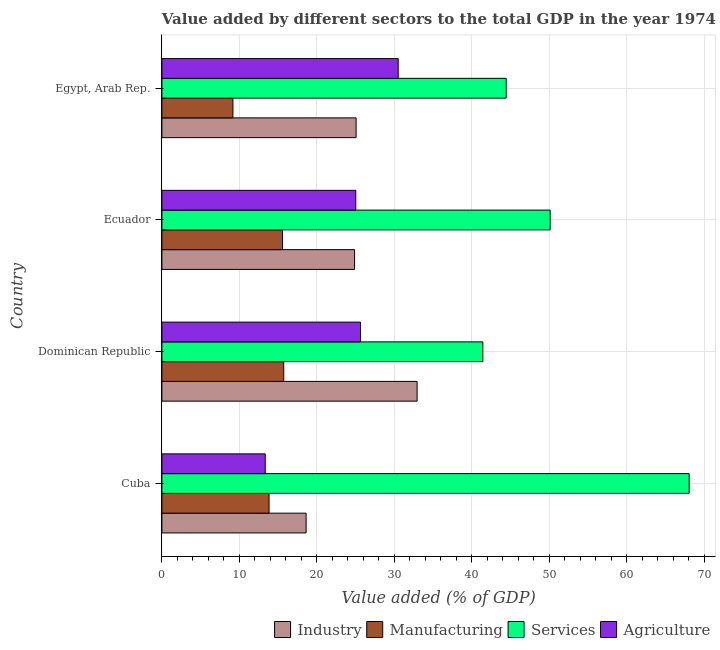How many different coloured bars are there?
Make the answer very short. 4. How many groups of bars are there?
Ensure brevity in your answer.  4. Are the number of bars per tick equal to the number of legend labels?
Ensure brevity in your answer.  Yes. Are the number of bars on each tick of the Y-axis equal?
Provide a short and direct response. Yes. How many bars are there on the 3rd tick from the bottom?
Provide a short and direct response. 4. What is the label of the 1st group of bars from the top?
Ensure brevity in your answer.  Egypt, Arab Rep. In how many cases, is the number of bars for a given country not equal to the number of legend labels?
Your answer should be compact. 0. What is the value added by industrial sector in Cuba?
Keep it short and to the point. 18.61. Across all countries, what is the maximum value added by industrial sector?
Offer a terse response. 32.94. Across all countries, what is the minimum value added by industrial sector?
Your response must be concise. 18.61. In which country was the value added by manufacturing sector maximum?
Give a very brief answer. Dominican Republic. In which country was the value added by manufacturing sector minimum?
Ensure brevity in your answer.  Egypt, Arab Rep. What is the total value added by agricultural sector in the graph?
Keep it short and to the point. 94.49. What is the difference between the value added by agricultural sector in Cuba and that in Dominican Republic?
Make the answer very short. -12.3. What is the difference between the value added by manufacturing sector in Dominican Republic and the value added by agricultural sector in Cuba?
Make the answer very short. 2.38. What is the average value added by agricultural sector per country?
Your answer should be compact. 23.62. What is the difference between the value added by manufacturing sector and value added by industrial sector in Ecuador?
Your response must be concise. -9.3. What is the ratio of the value added by manufacturing sector in Ecuador to that in Egypt, Arab Rep.?
Offer a very short reply. 1.7. Is the value added by manufacturing sector in Ecuador less than that in Egypt, Arab Rep.?
Ensure brevity in your answer.  No. What is the difference between the highest and the second highest value added by agricultural sector?
Your response must be concise. 4.86. What is the difference between the highest and the lowest value added by agricultural sector?
Provide a succinct answer. 17.16. What does the 4th bar from the top in Egypt, Arab Rep. represents?
Your answer should be compact. Industry. What does the 1st bar from the bottom in Dominican Republic represents?
Make the answer very short. Industry. How many bars are there?
Your answer should be compact. 16. Are the values on the major ticks of X-axis written in scientific E-notation?
Your answer should be compact. No. Where does the legend appear in the graph?
Give a very brief answer. Bottom right. What is the title of the graph?
Your answer should be very brief. Value added by different sectors to the total GDP in the year 1974. What is the label or title of the X-axis?
Provide a succinct answer. Value added (% of GDP). What is the Value added (% of GDP) in Industry in Cuba?
Provide a succinct answer. 18.61. What is the Value added (% of GDP) in Manufacturing in Cuba?
Make the answer very short. 13.83. What is the Value added (% of GDP) of Services in Cuba?
Ensure brevity in your answer.  68.05. What is the Value added (% of GDP) of Agriculture in Cuba?
Give a very brief answer. 13.34. What is the Value added (% of GDP) in Industry in Dominican Republic?
Provide a succinct answer. 32.94. What is the Value added (% of GDP) of Manufacturing in Dominican Republic?
Give a very brief answer. 15.72. What is the Value added (% of GDP) in Services in Dominican Republic?
Offer a terse response. 41.42. What is the Value added (% of GDP) of Agriculture in Dominican Republic?
Keep it short and to the point. 25.64. What is the Value added (% of GDP) in Industry in Ecuador?
Offer a terse response. 24.87. What is the Value added (% of GDP) of Manufacturing in Ecuador?
Your response must be concise. 15.56. What is the Value added (% of GDP) in Services in Ecuador?
Offer a terse response. 50.11. What is the Value added (% of GDP) in Agriculture in Ecuador?
Ensure brevity in your answer.  25.02. What is the Value added (% of GDP) of Industry in Egypt, Arab Rep.?
Make the answer very short. 25.07. What is the Value added (% of GDP) in Manufacturing in Egypt, Arab Rep.?
Keep it short and to the point. 9.17. What is the Value added (% of GDP) in Services in Egypt, Arab Rep.?
Keep it short and to the point. 44.44. What is the Value added (% of GDP) in Agriculture in Egypt, Arab Rep.?
Give a very brief answer. 30.5. Across all countries, what is the maximum Value added (% of GDP) of Industry?
Provide a succinct answer. 32.94. Across all countries, what is the maximum Value added (% of GDP) of Manufacturing?
Offer a very short reply. 15.72. Across all countries, what is the maximum Value added (% of GDP) of Services?
Your answer should be compact. 68.05. Across all countries, what is the maximum Value added (% of GDP) of Agriculture?
Offer a very short reply. 30.5. Across all countries, what is the minimum Value added (% of GDP) in Industry?
Offer a terse response. 18.61. Across all countries, what is the minimum Value added (% of GDP) of Manufacturing?
Your response must be concise. 9.17. Across all countries, what is the minimum Value added (% of GDP) in Services?
Your answer should be very brief. 41.42. Across all countries, what is the minimum Value added (% of GDP) in Agriculture?
Provide a succinct answer. 13.34. What is the total Value added (% of GDP) in Industry in the graph?
Ensure brevity in your answer.  101.48. What is the total Value added (% of GDP) in Manufacturing in the graph?
Offer a terse response. 54.28. What is the total Value added (% of GDP) of Services in the graph?
Provide a succinct answer. 204.02. What is the total Value added (% of GDP) of Agriculture in the graph?
Keep it short and to the point. 94.49. What is the difference between the Value added (% of GDP) of Industry in Cuba and that in Dominican Republic?
Provide a short and direct response. -14.33. What is the difference between the Value added (% of GDP) of Manufacturing in Cuba and that in Dominican Republic?
Your response must be concise. -1.89. What is the difference between the Value added (% of GDP) in Services in Cuba and that in Dominican Republic?
Offer a terse response. 26.62. What is the difference between the Value added (% of GDP) of Agriculture in Cuba and that in Dominican Republic?
Your answer should be very brief. -12.3. What is the difference between the Value added (% of GDP) in Industry in Cuba and that in Ecuador?
Your answer should be compact. -6.25. What is the difference between the Value added (% of GDP) in Manufacturing in Cuba and that in Ecuador?
Your answer should be very brief. -1.73. What is the difference between the Value added (% of GDP) in Services in Cuba and that in Ecuador?
Offer a terse response. 17.94. What is the difference between the Value added (% of GDP) of Agriculture in Cuba and that in Ecuador?
Keep it short and to the point. -11.68. What is the difference between the Value added (% of GDP) of Industry in Cuba and that in Egypt, Arab Rep.?
Provide a succinct answer. -6.45. What is the difference between the Value added (% of GDP) of Manufacturing in Cuba and that in Egypt, Arab Rep.?
Offer a terse response. 4.66. What is the difference between the Value added (% of GDP) of Services in Cuba and that in Egypt, Arab Rep.?
Give a very brief answer. 23.61. What is the difference between the Value added (% of GDP) in Agriculture in Cuba and that in Egypt, Arab Rep.?
Provide a succinct answer. -17.16. What is the difference between the Value added (% of GDP) of Industry in Dominican Republic and that in Ecuador?
Provide a short and direct response. 8.07. What is the difference between the Value added (% of GDP) in Manufacturing in Dominican Republic and that in Ecuador?
Your answer should be compact. 0.16. What is the difference between the Value added (% of GDP) in Services in Dominican Republic and that in Ecuador?
Your answer should be very brief. -8.69. What is the difference between the Value added (% of GDP) in Agriculture in Dominican Republic and that in Ecuador?
Ensure brevity in your answer.  0.61. What is the difference between the Value added (% of GDP) in Industry in Dominican Republic and that in Egypt, Arab Rep.?
Offer a very short reply. 7.87. What is the difference between the Value added (% of GDP) of Manufacturing in Dominican Republic and that in Egypt, Arab Rep.?
Provide a succinct answer. 6.56. What is the difference between the Value added (% of GDP) in Services in Dominican Republic and that in Egypt, Arab Rep.?
Provide a succinct answer. -3.01. What is the difference between the Value added (% of GDP) in Agriculture in Dominican Republic and that in Egypt, Arab Rep.?
Your response must be concise. -4.86. What is the difference between the Value added (% of GDP) in Industry in Ecuador and that in Egypt, Arab Rep.?
Your answer should be compact. -0.2. What is the difference between the Value added (% of GDP) in Manufacturing in Ecuador and that in Egypt, Arab Rep.?
Give a very brief answer. 6.4. What is the difference between the Value added (% of GDP) in Services in Ecuador and that in Egypt, Arab Rep.?
Your answer should be very brief. 5.67. What is the difference between the Value added (% of GDP) in Agriculture in Ecuador and that in Egypt, Arab Rep.?
Ensure brevity in your answer.  -5.48. What is the difference between the Value added (% of GDP) in Industry in Cuba and the Value added (% of GDP) in Manufacturing in Dominican Republic?
Your answer should be compact. 2.89. What is the difference between the Value added (% of GDP) in Industry in Cuba and the Value added (% of GDP) in Services in Dominican Republic?
Your answer should be compact. -22.81. What is the difference between the Value added (% of GDP) of Industry in Cuba and the Value added (% of GDP) of Agriculture in Dominican Republic?
Provide a succinct answer. -7.02. What is the difference between the Value added (% of GDP) of Manufacturing in Cuba and the Value added (% of GDP) of Services in Dominican Republic?
Give a very brief answer. -27.59. What is the difference between the Value added (% of GDP) in Manufacturing in Cuba and the Value added (% of GDP) in Agriculture in Dominican Republic?
Make the answer very short. -11.81. What is the difference between the Value added (% of GDP) of Services in Cuba and the Value added (% of GDP) of Agriculture in Dominican Republic?
Make the answer very short. 42.41. What is the difference between the Value added (% of GDP) in Industry in Cuba and the Value added (% of GDP) in Manufacturing in Ecuador?
Ensure brevity in your answer.  3.05. What is the difference between the Value added (% of GDP) of Industry in Cuba and the Value added (% of GDP) of Services in Ecuador?
Make the answer very short. -31.5. What is the difference between the Value added (% of GDP) in Industry in Cuba and the Value added (% of GDP) in Agriculture in Ecuador?
Offer a terse response. -6.41. What is the difference between the Value added (% of GDP) of Manufacturing in Cuba and the Value added (% of GDP) of Services in Ecuador?
Give a very brief answer. -36.28. What is the difference between the Value added (% of GDP) in Manufacturing in Cuba and the Value added (% of GDP) in Agriculture in Ecuador?
Make the answer very short. -11.19. What is the difference between the Value added (% of GDP) in Services in Cuba and the Value added (% of GDP) in Agriculture in Ecuador?
Your answer should be very brief. 43.03. What is the difference between the Value added (% of GDP) of Industry in Cuba and the Value added (% of GDP) of Manufacturing in Egypt, Arab Rep.?
Ensure brevity in your answer.  9.45. What is the difference between the Value added (% of GDP) in Industry in Cuba and the Value added (% of GDP) in Services in Egypt, Arab Rep.?
Keep it short and to the point. -25.82. What is the difference between the Value added (% of GDP) of Industry in Cuba and the Value added (% of GDP) of Agriculture in Egypt, Arab Rep.?
Your answer should be very brief. -11.88. What is the difference between the Value added (% of GDP) in Manufacturing in Cuba and the Value added (% of GDP) in Services in Egypt, Arab Rep.?
Provide a short and direct response. -30.61. What is the difference between the Value added (% of GDP) of Manufacturing in Cuba and the Value added (% of GDP) of Agriculture in Egypt, Arab Rep.?
Make the answer very short. -16.67. What is the difference between the Value added (% of GDP) in Services in Cuba and the Value added (% of GDP) in Agriculture in Egypt, Arab Rep.?
Provide a short and direct response. 37.55. What is the difference between the Value added (% of GDP) in Industry in Dominican Republic and the Value added (% of GDP) in Manufacturing in Ecuador?
Ensure brevity in your answer.  17.38. What is the difference between the Value added (% of GDP) in Industry in Dominican Republic and the Value added (% of GDP) in Services in Ecuador?
Provide a succinct answer. -17.17. What is the difference between the Value added (% of GDP) in Industry in Dominican Republic and the Value added (% of GDP) in Agriculture in Ecuador?
Make the answer very short. 7.92. What is the difference between the Value added (% of GDP) of Manufacturing in Dominican Republic and the Value added (% of GDP) of Services in Ecuador?
Provide a succinct answer. -34.39. What is the difference between the Value added (% of GDP) in Manufacturing in Dominican Republic and the Value added (% of GDP) in Agriculture in Ecuador?
Provide a succinct answer. -9.3. What is the difference between the Value added (% of GDP) in Services in Dominican Republic and the Value added (% of GDP) in Agriculture in Ecuador?
Offer a terse response. 16.4. What is the difference between the Value added (% of GDP) in Industry in Dominican Republic and the Value added (% of GDP) in Manufacturing in Egypt, Arab Rep.?
Offer a terse response. 23.77. What is the difference between the Value added (% of GDP) of Industry in Dominican Republic and the Value added (% of GDP) of Services in Egypt, Arab Rep.?
Provide a short and direct response. -11.5. What is the difference between the Value added (% of GDP) of Industry in Dominican Republic and the Value added (% of GDP) of Agriculture in Egypt, Arab Rep.?
Your answer should be very brief. 2.44. What is the difference between the Value added (% of GDP) in Manufacturing in Dominican Republic and the Value added (% of GDP) in Services in Egypt, Arab Rep.?
Your answer should be compact. -28.71. What is the difference between the Value added (% of GDP) of Manufacturing in Dominican Republic and the Value added (% of GDP) of Agriculture in Egypt, Arab Rep.?
Provide a short and direct response. -14.78. What is the difference between the Value added (% of GDP) in Services in Dominican Republic and the Value added (% of GDP) in Agriculture in Egypt, Arab Rep.?
Provide a short and direct response. 10.93. What is the difference between the Value added (% of GDP) of Industry in Ecuador and the Value added (% of GDP) of Manufacturing in Egypt, Arab Rep.?
Keep it short and to the point. 15.7. What is the difference between the Value added (% of GDP) of Industry in Ecuador and the Value added (% of GDP) of Services in Egypt, Arab Rep.?
Provide a succinct answer. -19.57. What is the difference between the Value added (% of GDP) in Industry in Ecuador and the Value added (% of GDP) in Agriculture in Egypt, Arab Rep.?
Provide a succinct answer. -5.63. What is the difference between the Value added (% of GDP) in Manufacturing in Ecuador and the Value added (% of GDP) in Services in Egypt, Arab Rep.?
Your answer should be very brief. -28.87. What is the difference between the Value added (% of GDP) of Manufacturing in Ecuador and the Value added (% of GDP) of Agriculture in Egypt, Arab Rep.?
Make the answer very short. -14.94. What is the difference between the Value added (% of GDP) in Services in Ecuador and the Value added (% of GDP) in Agriculture in Egypt, Arab Rep.?
Your answer should be very brief. 19.61. What is the average Value added (% of GDP) of Industry per country?
Offer a terse response. 25.37. What is the average Value added (% of GDP) in Manufacturing per country?
Offer a terse response. 13.57. What is the average Value added (% of GDP) in Services per country?
Provide a succinct answer. 51.01. What is the average Value added (% of GDP) of Agriculture per country?
Your answer should be compact. 23.62. What is the difference between the Value added (% of GDP) of Industry and Value added (% of GDP) of Manufacturing in Cuba?
Keep it short and to the point. 4.78. What is the difference between the Value added (% of GDP) in Industry and Value added (% of GDP) in Services in Cuba?
Give a very brief answer. -49.44. What is the difference between the Value added (% of GDP) of Industry and Value added (% of GDP) of Agriculture in Cuba?
Offer a very short reply. 5.28. What is the difference between the Value added (% of GDP) in Manufacturing and Value added (% of GDP) in Services in Cuba?
Your answer should be very brief. -54.22. What is the difference between the Value added (% of GDP) of Manufacturing and Value added (% of GDP) of Agriculture in Cuba?
Your response must be concise. 0.49. What is the difference between the Value added (% of GDP) in Services and Value added (% of GDP) in Agriculture in Cuba?
Offer a very short reply. 54.71. What is the difference between the Value added (% of GDP) of Industry and Value added (% of GDP) of Manufacturing in Dominican Republic?
Offer a very short reply. 17.22. What is the difference between the Value added (% of GDP) of Industry and Value added (% of GDP) of Services in Dominican Republic?
Keep it short and to the point. -8.48. What is the difference between the Value added (% of GDP) of Industry and Value added (% of GDP) of Agriculture in Dominican Republic?
Ensure brevity in your answer.  7.3. What is the difference between the Value added (% of GDP) of Manufacturing and Value added (% of GDP) of Services in Dominican Republic?
Your response must be concise. -25.7. What is the difference between the Value added (% of GDP) in Manufacturing and Value added (% of GDP) in Agriculture in Dominican Republic?
Make the answer very short. -9.91. What is the difference between the Value added (% of GDP) in Services and Value added (% of GDP) in Agriculture in Dominican Republic?
Your response must be concise. 15.79. What is the difference between the Value added (% of GDP) of Industry and Value added (% of GDP) of Manufacturing in Ecuador?
Offer a very short reply. 9.3. What is the difference between the Value added (% of GDP) in Industry and Value added (% of GDP) in Services in Ecuador?
Offer a terse response. -25.24. What is the difference between the Value added (% of GDP) of Industry and Value added (% of GDP) of Agriculture in Ecuador?
Offer a very short reply. -0.16. What is the difference between the Value added (% of GDP) in Manufacturing and Value added (% of GDP) in Services in Ecuador?
Make the answer very short. -34.55. What is the difference between the Value added (% of GDP) of Manufacturing and Value added (% of GDP) of Agriculture in Ecuador?
Offer a terse response. -9.46. What is the difference between the Value added (% of GDP) in Services and Value added (% of GDP) in Agriculture in Ecuador?
Give a very brief answer. 25.09. What is the difference between the Value added (% of GDP) in Industry and Value added (% of GDP) in Manufacturing in Egypt, Arab Rep.?
Your answer should be very brief. 15.9. What is the difference between the Value added (% of GDP) in Industry and Value added (% of GDP) in Services in Egypt, Arab Rep.?
Provide a short and direct response. -19.37. What is the difference between the Value added (% of GDP) in Industry and Value added (% of GDP) in Agriculture in Egypt, Arab Rep.?
Your answer should be very brief. -5.43. What is the difference between the Value added (% of GDP) of Manufacturing and Value added (% of GDP) of Services in Egypt, Arab Rep.?
Keep it short and to the point. -35.27. What is the difference between the Value added (% of GDP) in Manufacturing and Value added (% of GDP) in Agriculture in Egypt, Arab Rep.?
Give a very brief answer. -21.33. What is the difference between the Value added (% of GDP) in Services and Value added (% of GDP) in Agriculture in Egypt, Arab Rep.?
Your answer should be compact. 13.94. What is the ratio of the Value added (% of GDP) in Industry in Cuba to that in Dominican Republic?
Ensure brevity in your answer.  0.57. What is the ratio of the Value added (% of GDP) of Manufacturing in Cuba to that in Dominican Republic?
Give a very brief answer. 0.88. What is the ratio of the Value added (% of GDP) in Services in Cuba to that in Dominican Republic?
Provide a succinct answer. 1.64. What is the ratio of the Value added (% of GDP) of Agriculture in Cuba to that in Dominican Republic?
Give a very brief answer. 0.52. What is the ratio of the Value added (% of GDP) of Industry in Cuba to that in Ecuador?
Ensure brevity in your answer.  0.75. What is the ratio of the Value added (% of GDP) in Manufacturing in Cuba to that in Ecuador?
Offer a terse response. 0.89. What is the ratio of the Value added (% of GDP) of Services in Cuba to that in Ecuador?
Offer a very short reply. 1.36. What is the ratio of the Value added (% of GDP) in Agriculture in Cuba to that in Ecuador?
Your response must be concise. 0.53. What is the ratio of the Value added (% of GDP) of Industry in Cuba to that in Egypt, Arab Rep.?
Your answer should be very brief. 0.74. What is the ratio of the Value added (% of GDP) in Manufacturing in Cuba to that in Egypt, Arab Rep.?
Your response must be concise. 1.51. What is the ratio of the Value added (% of GDP) in Services in Cuba to that in Egypt, Arab Rep.?
Offer a terse response. 1.53. What is the ratio of the Value added (% of GDP) of Agriculture in Cuba to that in Egypt, Arab Rep.?
Your answer should be very brief. 0.44. What is the ratio of the Value added (% of GDP) of Industry in Dominican Republic to that in Ecuador?
Give a very brief answer. 1.32. What is the ratio of the Value added (% of GDP) of Manufacturing in Dominican Republic to that in Ecuador?
Provide a succinct answer. 1.01. What is the ratio of the Value added (% of GDP) in Services in Dominican Republic to that in Ecuador?
Make the answer very short. 0.83. What is the ratio of the Value added (% of GDP) of Agriculture in Dominican Republic to that in Ecuador?
Provide a succinct answer. 1.02. What is the ratio of the Value added (% of GDP) in Industry in Dominican Republic to that in Egypt, Arab Rep.?
Offer a terse response. 1.31. What is the ratio of the Value added (% of GDP) in Manufacturing in Dominican Republic to that in Egypt, Arab Rep.?
Keep it short and to the point. 1.72. What is the ratio of the Value added (% of GDP) in Services in Dominican Republic to that in Egypt, Arab Rep.?
Give a very brief answer. 0.93. What is the ratio of the Value added (% of GDP) of Agriculture in Dominican Republic to that in Egypt, Arab Rep.?
Make the answer very short. 0.84. What is the ratio of the Value added (% of GDP) in Manufacturing in Ecuador to that in Egypt, Arab Rep.?
Ensure brevity in your answer.  1.7. What is the ratio of the Value added (% of GDP) in Services in Ecuador to that in Egypt, Arab Rep.?
Provide a succinct answer. 1.13. What is the ratio of the Value added (% of GDP) of Agriculture in Ecuador to that in Egypt, Arab Rep.?
Your answer should be compact. 0.82. What is the difference between the highest and the second highest Value added (% of GDP) of Industry?
Keep it short and to the point. 7.87. What is the difference between the highest and the second highest Value added (% of GDP) in Manufacturing?
Offer a very short reply. 0.16. What is the difference between the highest and the second highest Value added (% of GDP) in Services?
Your answer should be compact. 17.94. What is the difference between the highest and the second highest Value added (% of GDP) in Agriculture?
Your response must be concise. 4.86. What is the difference between the highest and the lowest Value added (% of GDP) in Industry?
Give a very brief answer. 14.33. What is the difference between the highest and the lowest Value added (% of GDP) in Manufacturing?
Ensure brevity in your answer.  6.56. What is the difference between the highest and the lowest Value added (% of GDP) of Services?
Ensure brevity in your answer.  26.62. What is the difference between the highest and the lowest Value added (% of GDP) of Agriculture?
Your answer should be very brief. 17.16. 